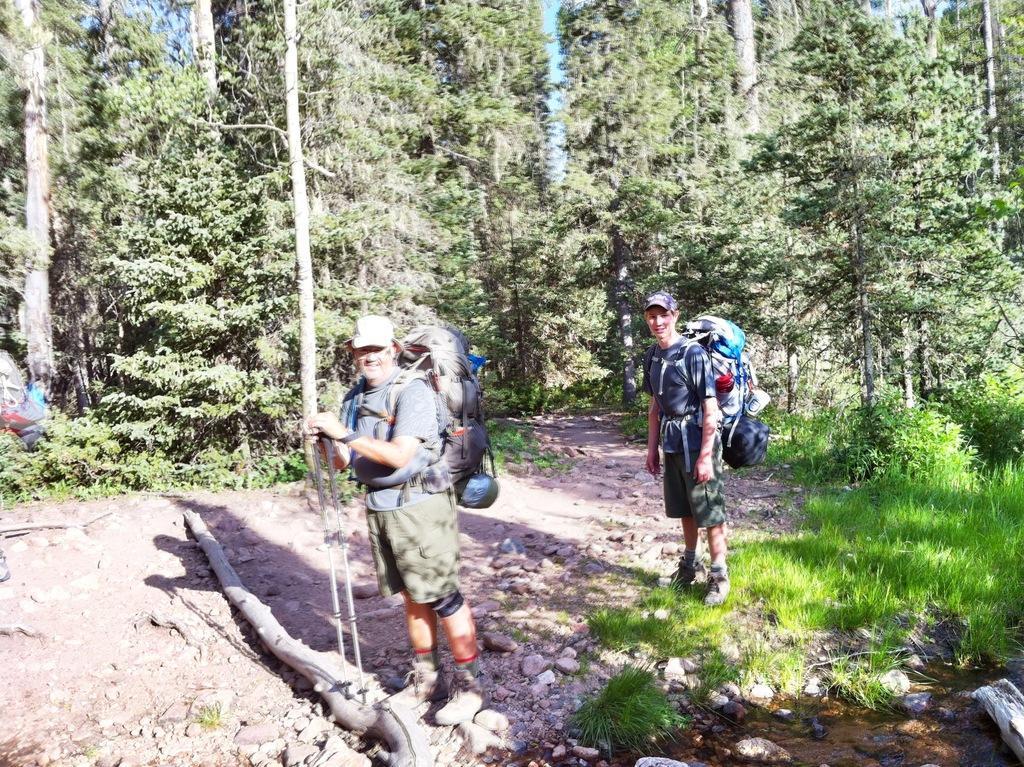Could you give a brief overview of what you see in this image? In this image we can see two men wearing bags are standing on the ground. One person is holding sticks in his hand. In the foreground of the image we can see the wood log and some stones. On the right side of the image we can see water and grass. At the top of the image we can see a group of trees and the sky. 